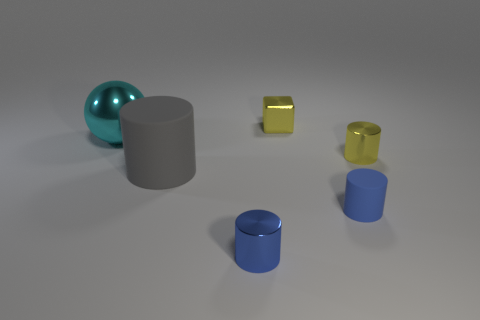Subtract all yellow cylinders. How many cylinders are left? 3 Subtract 1 cylinders. How many cylinders are left? 3 Subtract all yellow cylinders. How many cylinders are left? 3 Subtract all cyan cylinders. Subtract all blue blocks. How many cylinders are left? 4 Add 2 tiny yellow metal cubes. How many objects exist? 8 Subtract all balls. How many objects are left? 5 Add 4 tiny yellow shiny cubes. How many tiny yellow shiny cubes are left? 5 Add 3 yellow cubes. How many yellow cubes exist? 4 Subtract 1 blue cylinders. How many objects are left? 5 Subtract all gray objects. Subtract all large gray cylinders. How many objects are left? 4 